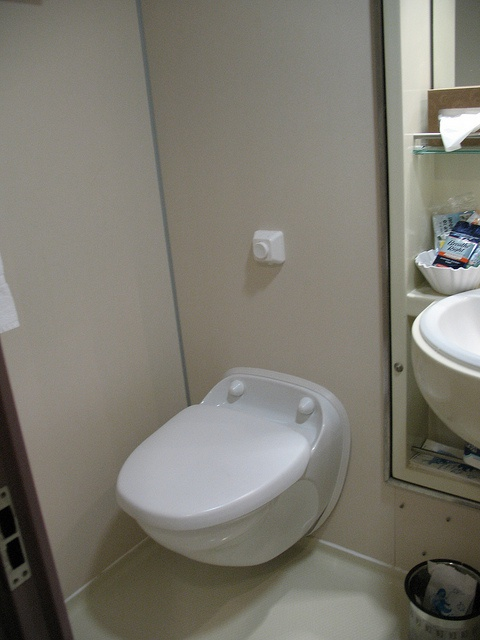Describe the objects in this image and their specific colors. I can see toilet in gray, darkgray, and lightgray tones, sink in gray, lightgray, and darkgray tones, and bowl in gray, darkgray, and lightgray tones in this image. 